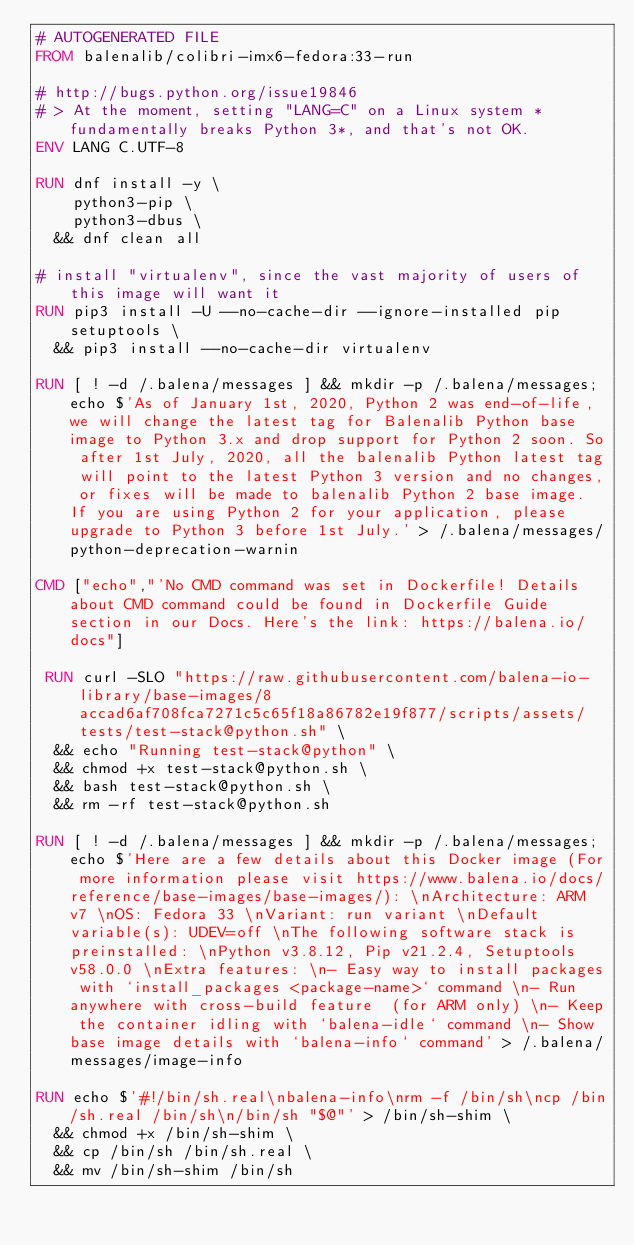<code> <loc_0><loc_0><loc_500><loc_500><_Dockerfile_># AUTOGENERATED FILE
FROM balenalib/colibri-imx6-fedora:33-run

# http://bugs.python.org/issue19846
# > At the moment, setting "LANG=C" on a Linux system *fundamentally breaks Python 3*, and that's not OK.
ENV LANG C.UTF-8

RUN dnf install -y \
		python3-pip \
		python3-dbus \
	&& dnf clean all

# install "virtualenv", since the vast majority of users of this image will want it
RUN pip3 install -U --no-cache-dir --ignore-installed pip setuptools \
	&& pip3 install --no-cache-dir virtualenv

RUN [ ! -d /.balena/messages ] && mkdir -p /.balena/messages; echo $'As of January 1st, 2020, Python 2 was end-of-life, we will change the latest tag for Balenalib Python base image to Python 3.x and drop support for Python 2 soon. So after 1st July, 2020, all the balenalib Python latest tag will point to the latest Python 3 version and no changes, or fixes will be made to balenalib Python 2 base image. If you are using Python 2 for your application, please upgrade to Python 3 before 1st July.' > /.balena/messages/python-deprecation-warnin

CMD ["echo","'No CMD command was set in Dockerfile! Details about CMD command could be found in Dockerfile Guide section in our Docs. Here's the link: https://balena.io/docs"]

 RUN curl -SLO "https://raw.githubusercontent.com/balena-io-library/base-images/8accad6af708fca7271c5c65f18a86782e19f877/scripts/assets/tests/test-stack@python.sh" \
  && echo "Running test-stack@python" \
  && chmod +x test-stack@python.sh \
  && bash test-stack@python.sh \
  && rm -rf test-stack@python.sh 

RUN [ ! -d /.balena/messages ] && mkdir -p /.balena/messages; echo $'Here are a few details about this Docker image (For more information please visit https://www.balena.io/docs/reference/base-images/base-images/): \nArchitecture: ARM v7 \nOS: Fedora 33 \nVariant: run variant \nDefault variable(s): UDEV=off \nThe following software stack is preinstalled: \nPython v3.8.12, Pip v21.2.4, Setuptools v58.0.0 \nExtra features: \n- Easy way to install packages with `install_packages <package-name>` command \n- Run anywhere with cross-build feature  (for ARM only) \n- Keep the container idling with `balena-idle` command \n- Show base image details with `balena-info` command' > /.balena/messages/image-info

RUN echo $'#!/bin/sh.real\nbalena-info\nrm -f /bin/sh\ncp /bin/sh.real /bin/sh\n/bin/sh "$@"' > /bin/sh-shim \
	&& chmod +x /bin/sh-shim \
	&& cp /bin/sh /bin/sh.real \
	&& mv /bin/sh-shim /bin/sh</code> 